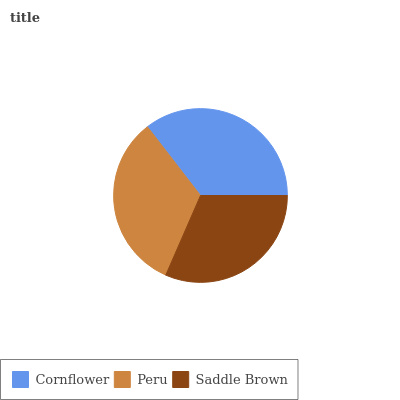Is Saddle Brown the minimum?
Answer yes or no. Yes. Is Cornflower the maximum?
Answer yes or no. Yes. Is Peru the minimum?
Answer yes or no. No. Is Peru the maximum?
Answer yes or no. No. Is Cornflower greater than Peru?
Answer yes or no. Yes. Is Peru less than Cornflower?
Answer yes or no. Yes. Is Peru greater than Cornflower?
Answer yes or no. No. Is Cornflower less than Peru?
Answer yes or no. No. Is Peru the high median?
Answer yes or no. Yes. Is Peru the low median?
Answer yes or no. Yes. Is Saddle Brown the high median?
Answer yes or no. No. Is Cornflower the low median?
Answer yes or no. No. 